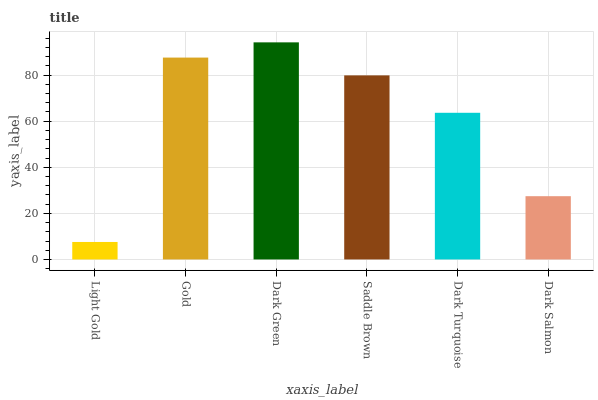Is Light Gold the minimum?
Answer yes or no. Yes. Is Dark Green the maximum?
Answer yes or no. Yes. Is Gold the minimum?
Answer yes or no. No. Is Gold the maximum?
Answer yes or no. No. Is Gold greater than Light Gold?
Answer yes or no. Yes. Is Light Gold less than Gold?
Answer yes or no. Yes. Is Light Gold greater than Gold?
Answer yes or no. No. Is Gold less than Light Gold?
Answer yes or no. No. Is Saddle Brown the high median?
Answer yes or no. Yes. Is Dark Turquoise the low median?
Answer yes or no. Yes. Is Dark Turquoise the high median?
Answer yes or no. No. Is Gold the low median?
Answer yes or no. No. 